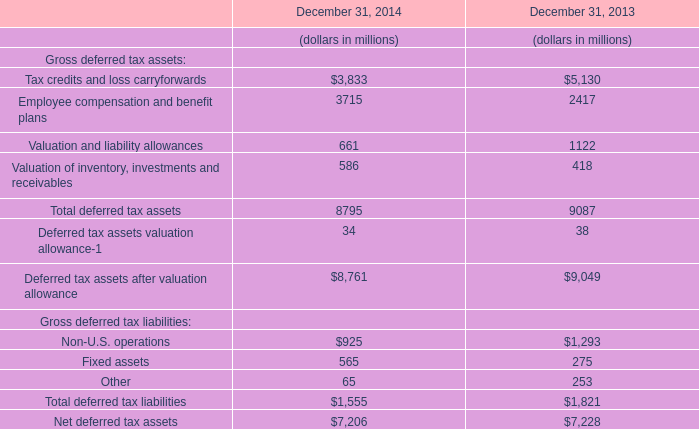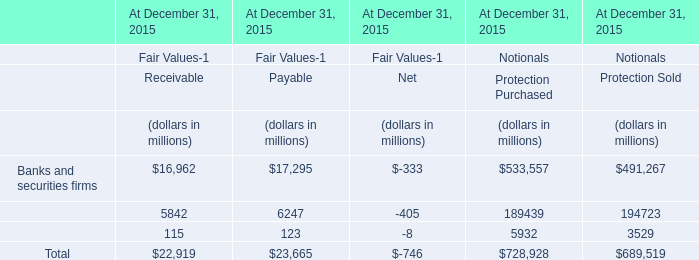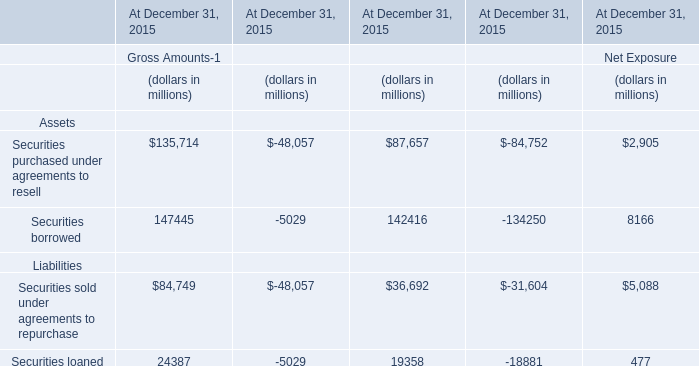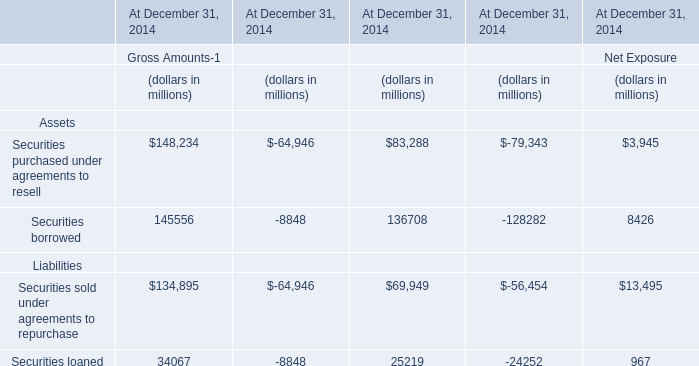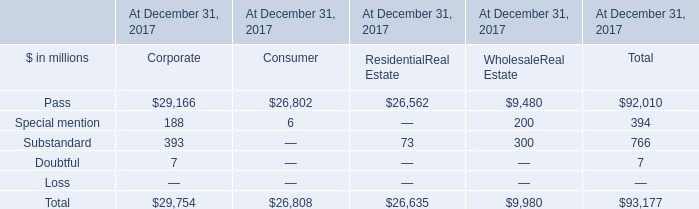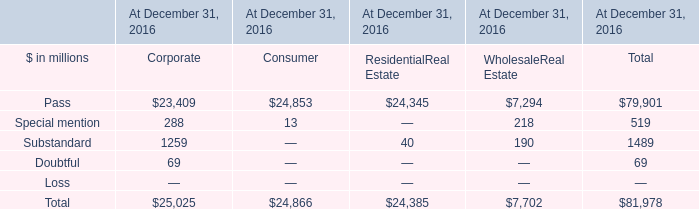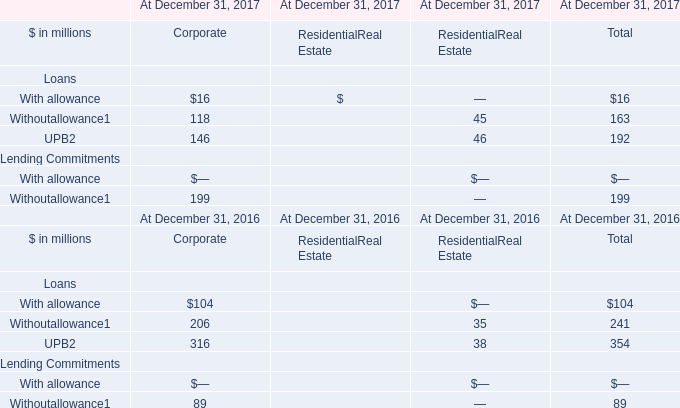What's the total amount of the Lending Commitments in the years where Loans greater than 0? (in million) 
Computations: (199 + 89)
Answer: 288.0. 